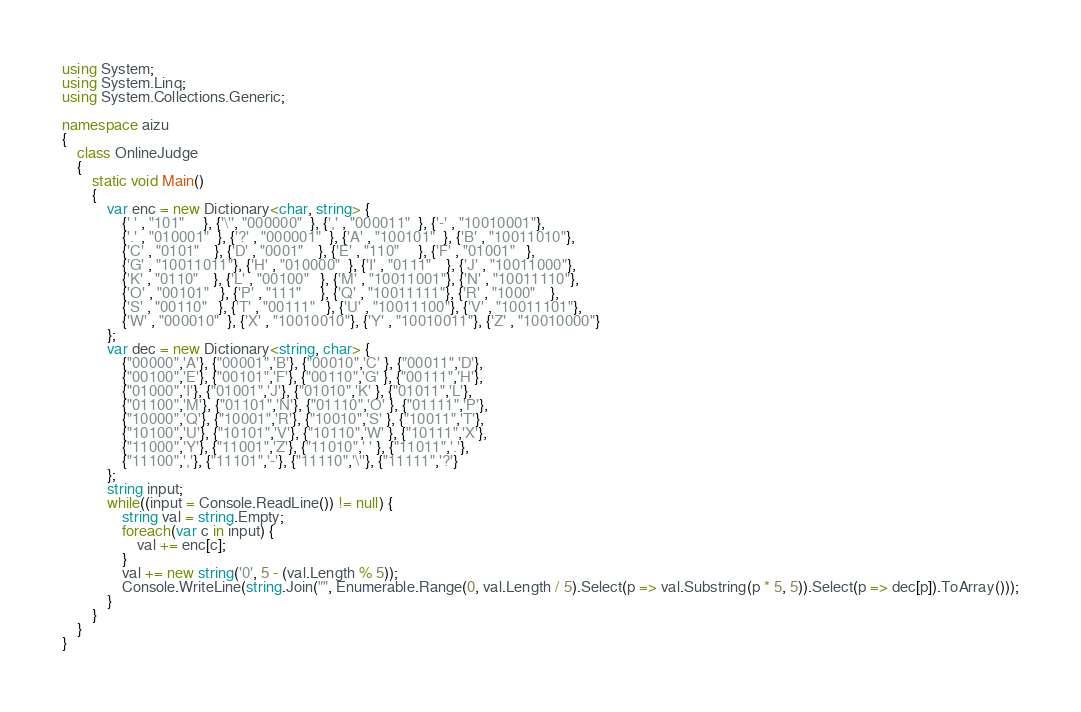<code> <loc_0><loc_0><loc_500><loc_500><_C#_>using System;
using System.Linq;
using System.Collections.Generic;
 
namespace aizu
{
    class OnlineJudge
    {
        static void Main()
        {
            var enc = new Dictionary<char, string> {
                {' ' , "101"     }, {'\'', "000000"  }, {',' , "000011"  }, {'-' , "10010001"},
                {'.' , "010001"  }, {'?' , "000001"  }, {'A' , "100101"  }, {'B' , "10011010"},
                {'C' , "0101"    }, {'D' , "0001"    }, {'E' , "110"     }, {'F' , "01001"   },
                {'G' , "10011011"}, {'H' , "010000"  }, {'I' , "0111"    }, {'J' , "10011000"},
                {'K' , "0110"    }, {'L' , "00100"   }, {'M' , "10011001"}, {'N' , "10011110"},
                {'O' , "00101"   }, {'P' , "111"     }, {'Q' , "10011111"}, {'R' , "1000"    },
                {'S' , "00110"   }, {'T' , "00111"   }, {'U' , "10011100"}, {'V' , "10011101"},
                {'W' , "000010"  }, {'X' , "10010010"}, {'Y' , "10010011"}, {'Z' , "10010000"}
            };
            var dec = new Dictionary<string, char> {
                {"00000",'A'}, {"00001",'B'}, {"00010",'C' }, {"00011",'D'},
                {"00100",'E'}, {"00101",'F'}, {"00110",'G' }, {"00111",'H'},
                {"01000",'I'}, {"01001",'J'}, {"01010",'K' }, {"01011",'L'},
                {"01100",'M'}, {"01101",'N'}, {"01110",'O' }, {"01111",'P'},
                {"10000",'Q'}, {"10001",'R'}, {"10010",'S' }, {"10011",'T'},
                {"10100",'U'}, {"10101",'V'}, {"10110",'W' }, {"10111",'X'},
                {"11000",'Y'}, {"11001",'Z'}, {"11010",' ' }, {"11011",'.'},
                {"11100",','}, {"11101",'-'}, {"11110",'\''}, {"11111",'?'}
            };
            string input;
            while((input = Console.ReadLine()) != null) {
                string val = string.Empty;
                foreach(var c in input) {
                    val += enc[c];
                }
                val += new string('0', 5 - (val.Length % 5));
                Console.WriteLine(string.Join("", Enumerable.Range(0, val.Length / 5).Select(p => val.Substring(p * 5, 5)).Select(p => dec[p]).ToArray()));
            }
        }
    }
}</code> 